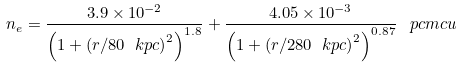<formula> <loc_0><loc_0><loc_500><loc_500>n _ { e } = \frac { 3 . 9 \times 1 0 ^ { - 2 } } { \left ( 1 + \left ( r / 8 0 \ k p c \right ) ^ { 2 } \right ) ^ { 1 . 8 } } + \frac { 4 . 0 5 \times 1 0 ^ { - 3 } } { \left ( 1 + \left ( r / 2 8 0 \ k p c \right ) ^ { 2 } \right ) ^ { 0 . 8 7 } } \, \ p c m c u</formula> 